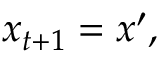Convert formula to latex. <formula><loc_0><loc_0><loc_500><loc_500>x _ { t + 1 } = x ^ { \prime } ,</formula> 